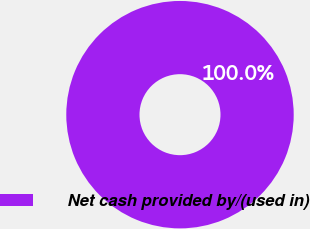<chart> <loc_0><loc_0><loc_500><loc_500><pie_chart><fcel>Net cash provided by/(used in)<nl><fcel>100.0%<nl></chart> 